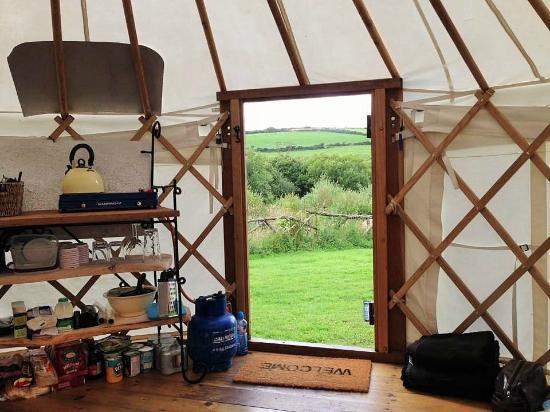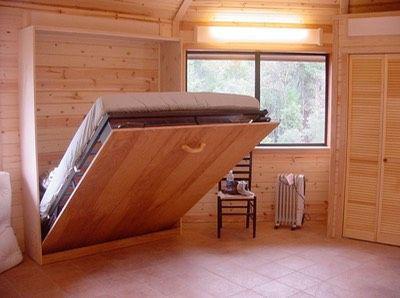The first image is the image on the left, the second image is the image on the right. Examine the images to the left and right. Is the description "One of the images has a ceiling fixture with at least three lights and the other image has no ceiling lights." accurate? Answer yes or no. No. The first image is the image on the left, the second image is the image on the right. Given the left and right images, does the statement "There are at least three chairs around a table located near the windows in one of the images." hold true? Answer yes or no. No. 